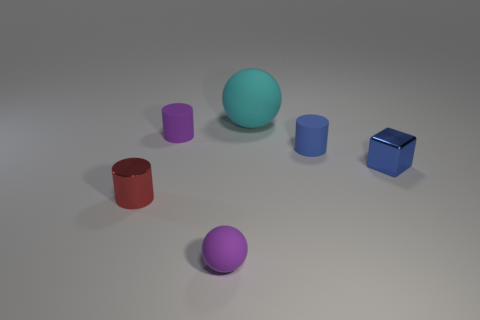Add 2 balls. How many objects exist? 8 Subtract all tiny rubber cylinders. How many cylinders are left? 1 Subtract all purple cylinders. How many cylinders are left? 2 Add 2 big shiny balls. How many big shiny balls exist? 2 Subtract 1 blue cylinders. How many objects are left? 5 Subtract all blocks. How many objects are left? 5 Subtract 2 balls. How many balls are left? 0 Subtract all cyan spheres. Subtract all brown blocks. How many spheres are left? 1 Subtract all brown cylinders. How many blue balls are left? 0 Subtract all tiny purple rubber spheres. Subtract all blue cylinders. How many objects are left? 4 